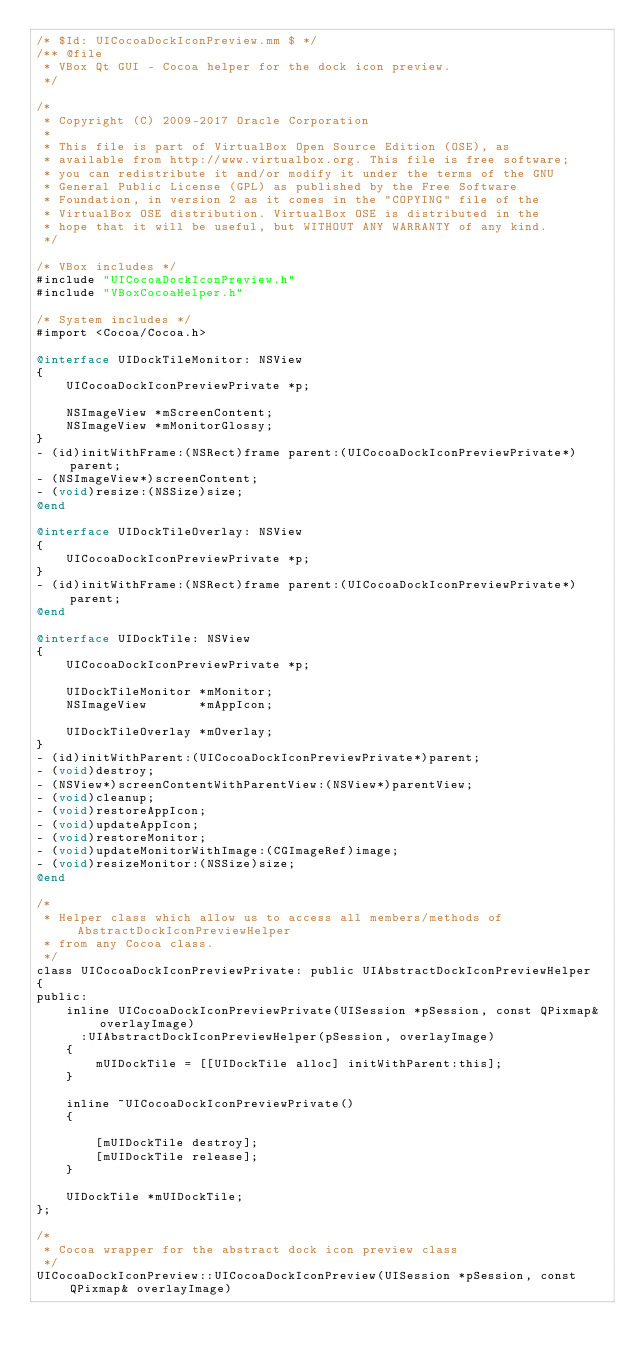<code> <loc_0><loc_0><loc_500><loc_500><_ObjectiveC_>/* $Id: UICocoaDockIconPreview.mm $ */
/** @file
 * VBox Qt GUI - Cocoa helper for the dock icon preview.
 */

/*
 * Copyright (C) 2009-2017 Oracle Corporation
 *
 * This file is part of VirtualBox Open Source Edition (OSE), as
 * available from http://www.virtualbox.org. This file is free software;
 * you can redistribute it and/or modify it under the terms of the GNU
 * General Public License (GPL) as published by the Free Software
 * Foundation, in version 2 as it comes in the "COPYING" file of the
 * VirtualBox OSE distribution. VirtualBox OSE is distributed in the
 * hope that it will be useful, but WITHOUT ANY WARRANTY of any kind.
 */

/* VBox includes */
#include "UICocoaDockIconPreview.h"
#include "VBoxCocoaHelper.h"

/* System includes */
#import <Cocoa/Cocoa.h>

@interface UIDockTileMonitor: NSView
{
    UICocoaDockIconPreviewPrivate *p;

    NSImageView *mScreenContent;
    NSImageView *mMonitorGlossy;
}
- (id)initWithFrame:(NSRect)frame parent:(UICocoaDockIconPreviewPrivate*)parent;
- (NSImageView*)screenContent;
- (void)resize:(NSSize)size;
@end

@interface UIDockTileOverlay: NSView
{
    UICocoaDockIconPreviewPrivate *p;
}
- (id)initWithFrame:(NSRect)frame parent:(UICocoaDockIconPreviewPrivate*)parent;
@end

@interface UIDockTile: NSView
{
    UICocoaDockIconPreviewPrivate *p;

    UIDockTileMonitor *mMonitor;
    NSImageView       *mAppIcon;

    UIDockTileOverlay *mOverlay;
}
- (id)initWithParent:(UICocoaDockIconPreviewPrivate*)parent;
- (void)destroy;
- (NSView*)screenContentWithParentView:(NSView*)parentView;
- (void)cleanup;
- (void)restoreAppIcon;
- (void)updateAppIcon;
- (void)restoreMonitor;
- (void)updateMonitorWithImage:(CGImageRef)image;
- (void)resizeMonitor:(NSSize)size;
@end

/*
 * Helper class which allow us to access all members/methods of AbstractDockIconPreviewHelper
 * from any Cocoa class.
 */
class UICocoaDockIconPreviewPrivate: public UIAbstractDockIconPreviewHelper
{
public:
    inline UICocoaDockIconPreviewPrivate(UISession *pSession, const QPixmap& overlayImage)
      :UIAbstractDockIconPreviewHelper(pSession, overlayImage)
    {
        mUIDockTile = [[UIDockTile alloc] initWithParent:this];
    }

    inline ~UICocoaDockIconPreviewPrivate()
    {

        [mUIDockTile destroy];
        [mUIDockTile release];
    }

    UIDockTile *mUIDockTile;
};

/*
 * Cocoa wrapper for the abstract dock icon preview class
 */
UICocoaDockIconPreview::UICocoaDockIconPreview(UISession *pSession, const QPixmap& overlayImage)</code> 